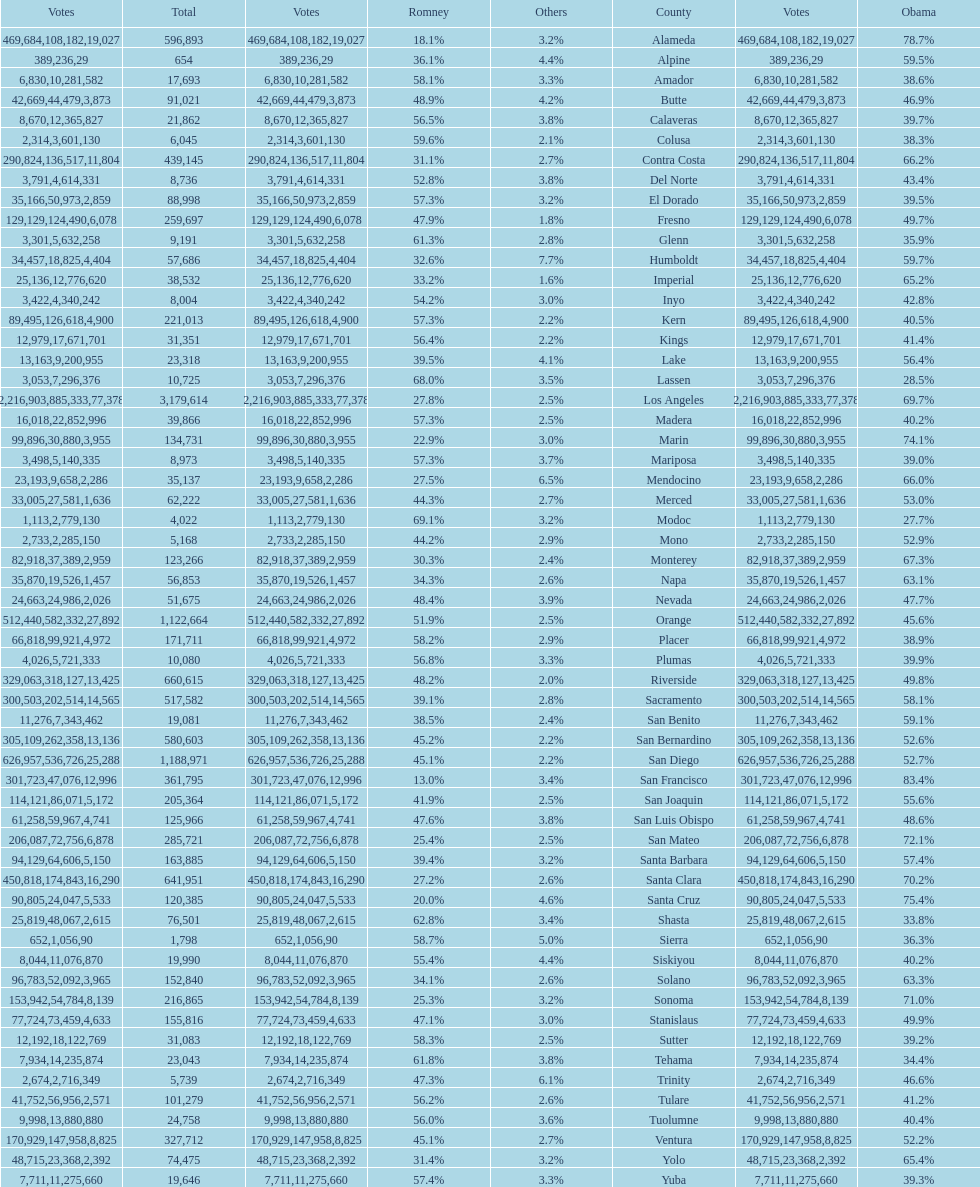What is the number of votes for obama for del norte and el dorado counties? 38957. 